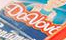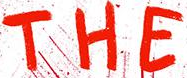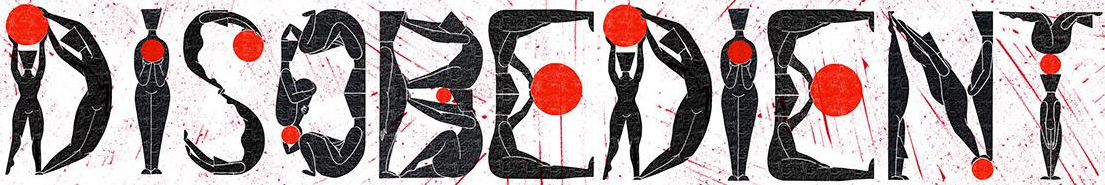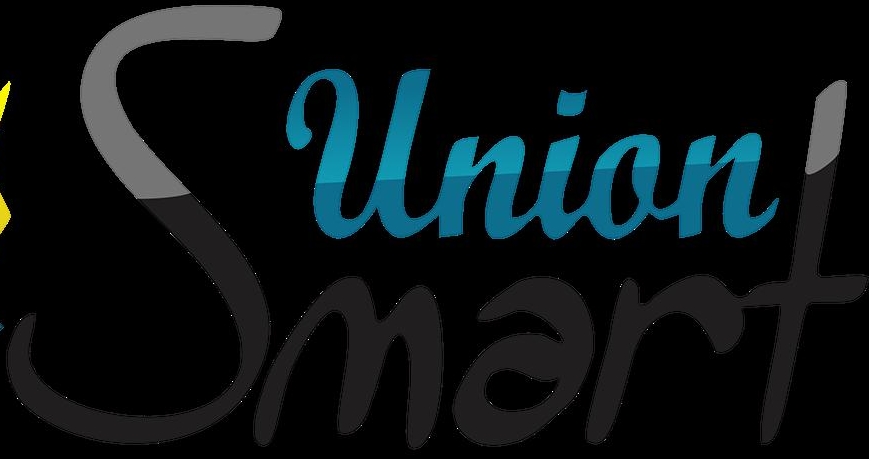Read the text content from these images in order, separated by a semicolon. Davbv; THE; DISOBEDIENT; Smart 